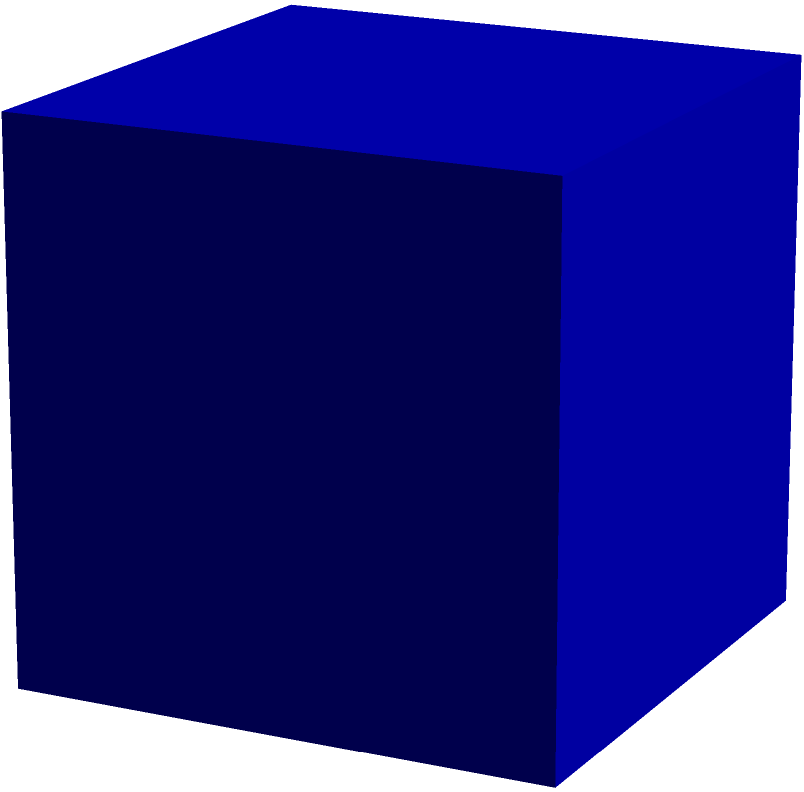As part of a University of Toronto promotional campaign, you're designing a tetrahedron-shaped paperweight to showcase the university's innovative spirit. If the edge length of this regular tetrahedron is 10 cm, what is its total surface area? Round your answer to the nearest square centimeter. Let's approach this step-by-step:

1) For a regular tetrahedron, all faces are congruent equilateral triangles.

2) The surface area will be the sum of the areas of these four triangles.

3) To find the area of one triangular face, we need to use the formula for the area of an equilateral triangle:

   $A = \frac{\sqrt{3}}{4}a^2$

   where $a$ is the length of one side.

4) Given: $a = 10$ cm

5) Area of one face:
   $A = \frac{\sqrt{3}}{4}(10)^2 = 25\sqrt{3}$ cm²

6) Total surface area:
   $SA = 4 \times 25\sqrt{3} = 100\sqrt{3}$ cm²

7) $100\sqrt{3} \approx 173.2051$ cm²

8) Rounding to the nearest square centimeter: 173 cm²
Answer: 173 cm² 